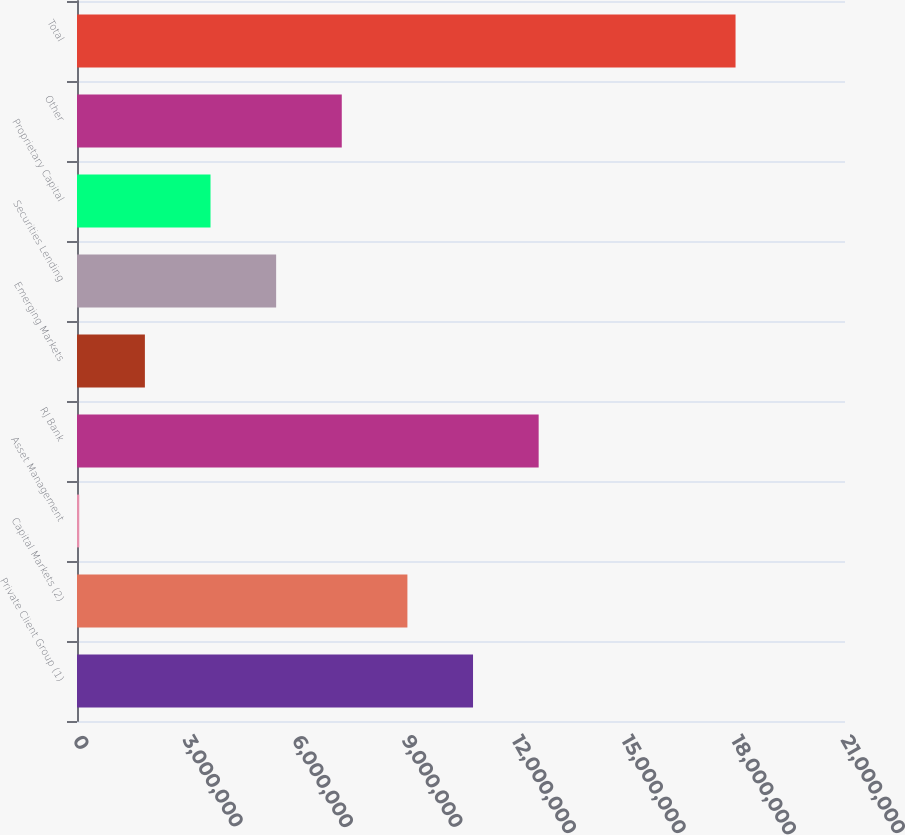Convert chart to OTSL. <chart><loc_0><loc_0><loc_500><loc_500><bar_chart><fcel>Private Client Group (1)<fcel>Capital Markets (2)<fcel>Asset Management<fcel>RJ Bank<fcel>Emerging Markets<fcel>Securities Lending<fcel>Proprietary Capital<fcel>Other<fcel>Total<nl><fcel>1.08289e+07<fcel>9.03439e+06<fcel>61793<fcel>1.26234e+07<fcel>1.85631e+06<fcel>5.44535e+06<fcel>3.65083e+06<fcel>7.23987e+06<fcel>1.8007e+07<nl></chart> 